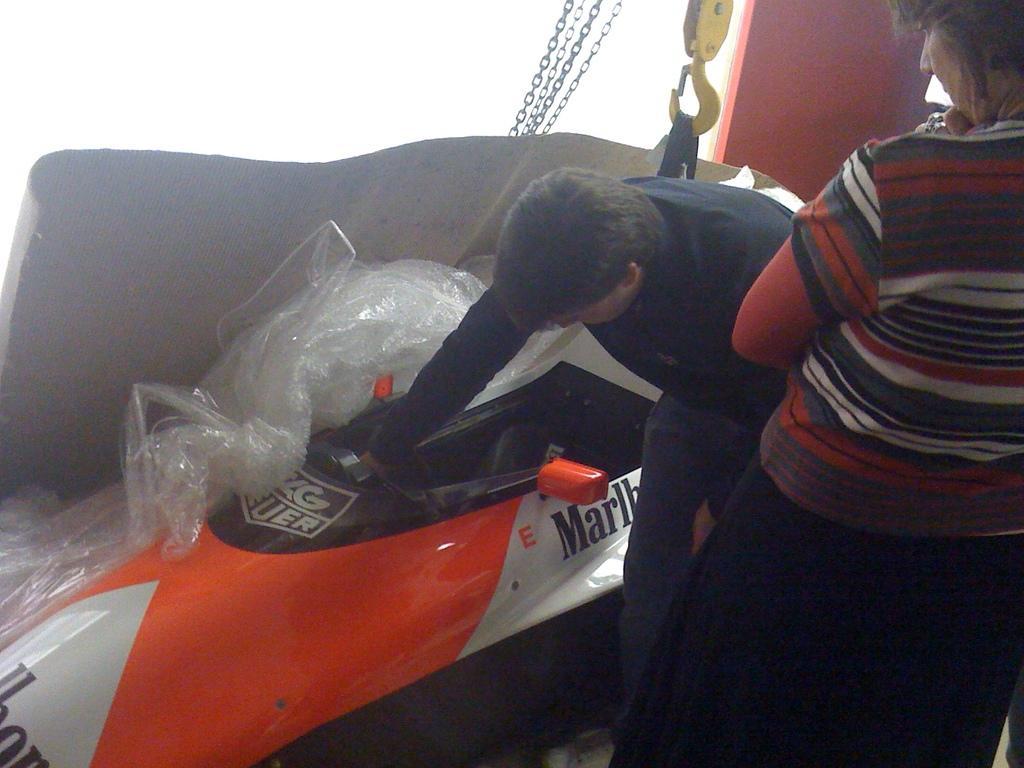How would you summarize this image in a sentence or two? In this image we can see there are two persons standing on the floor and one person holding car and there are boards and thread attached to the crane. 